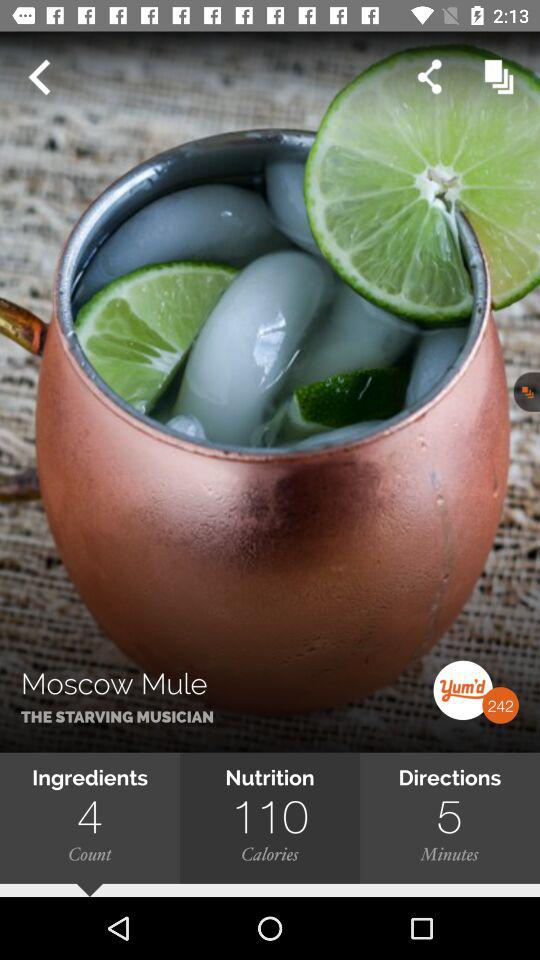How many minutes are in the Moscow Mule directions?
Answer the question using a single word or phrase. 5 